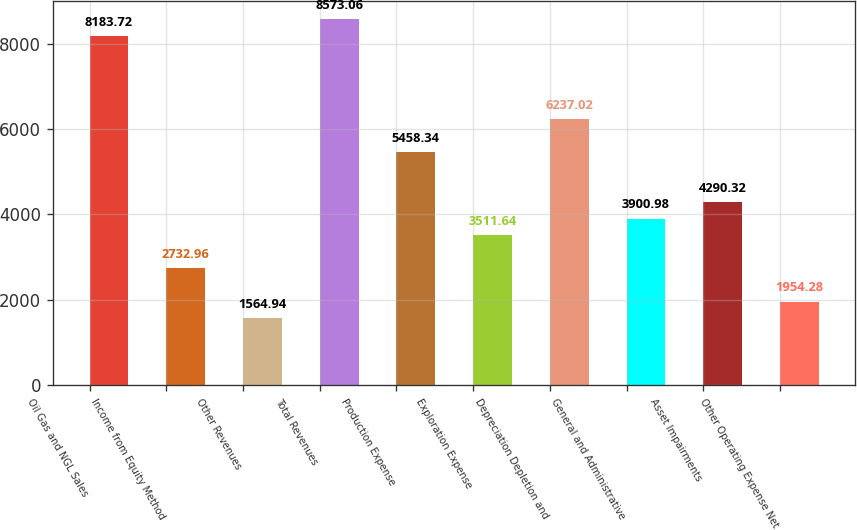Convert chart to OTSL. <chart><loc_0><loc_0><loc_500><loc_500><bar_chart><fcel>Oil Gas and NGL Sales<fcel>Income from Equity Method<fcel>Other Revenues<fcel>Total Revenues<fcel>Production Expense<fcel>Exploration Expense<fcel>Depreciation Depletion and<fcel>General and Administrative<fcel>Asset Impairments<fcel>Other Operating Expense Net<nl><fcel>8183.72<fcel>2732.96<fcel>1564.94<fcel>8573.06<fcel>5458.34<fcel>3511.64<fcel>6237.02<fcel>3900.98<fcel>4290.32<fcel>1954.28<nl></chart> 